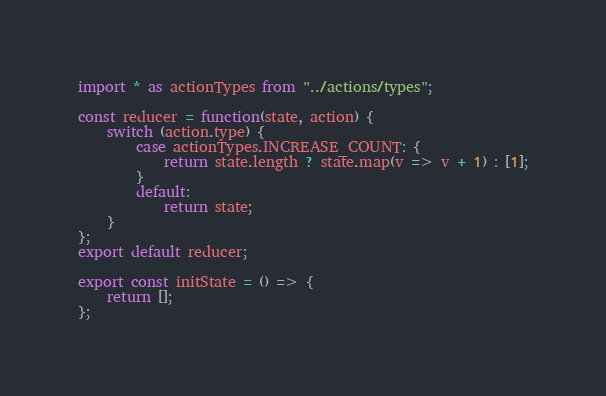Convert code to text. <code><loc_0><loc_0><loc_500><loc_500><_JavaScript_>import * as actionTypes from "../actions/types";

const reducer = function(state, action) {
    switch (action.type) {
        case actionTypes.INCREASE_COUNT: {
            return state.length ? state.map(v => v + 1) : [1];
        }
        default:
            return state;
    }
};
export default reducer;

export const initState = () => {
    return [];
};
</code> 